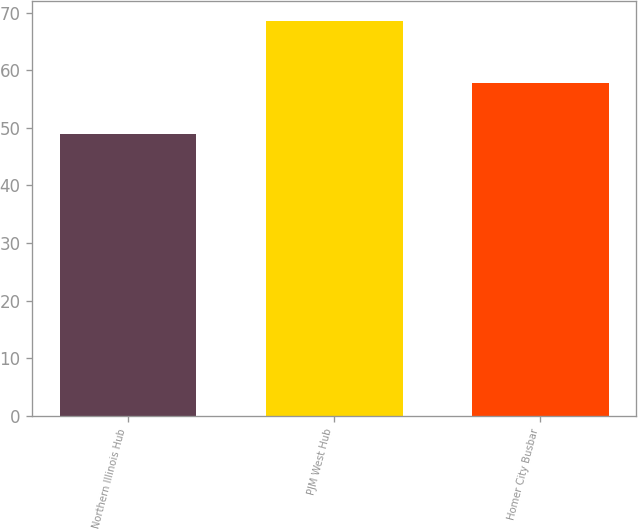Convert chart to OTSL. <chart><loc_0><loc_0><loc_500><loc_500><bar_chart><fcel>Northern Illinois Hub<fcel>PJM West Hub<fcel>Homer City Busbar<nl><fcel>49.01<fcel>68.56<fcel>57.72<nl></chart> 